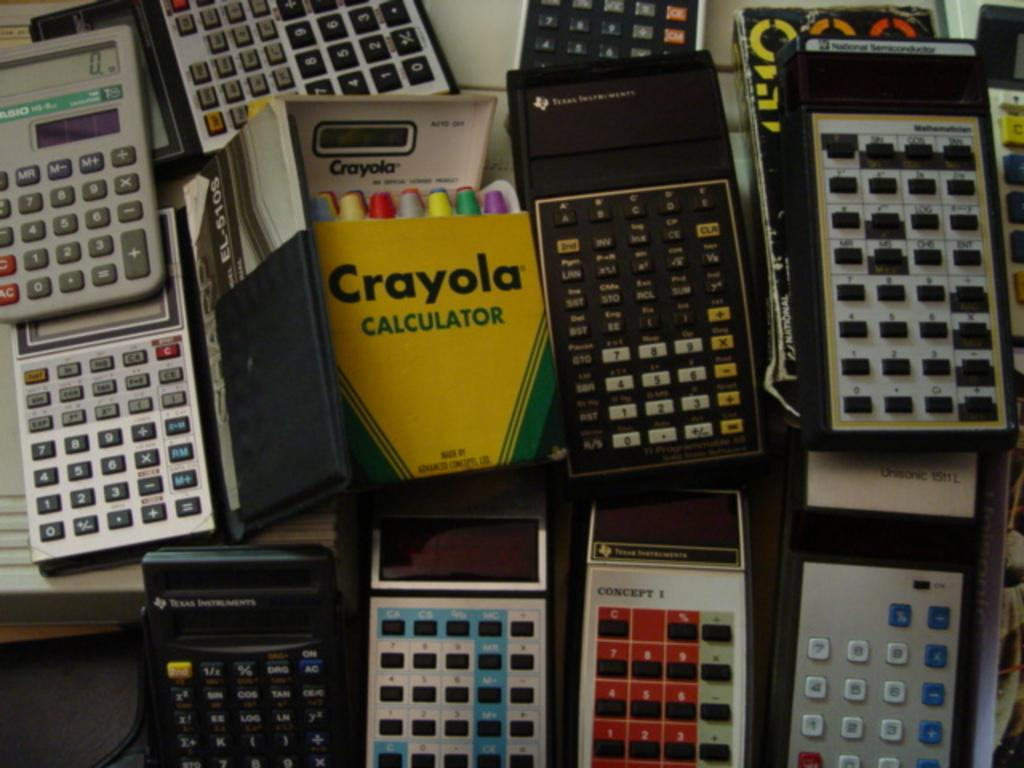<image>
Offer a succinct explanation of the picture presented. A fun Crayola Calculator sits in the middle of several old Texas Instrument calculators 